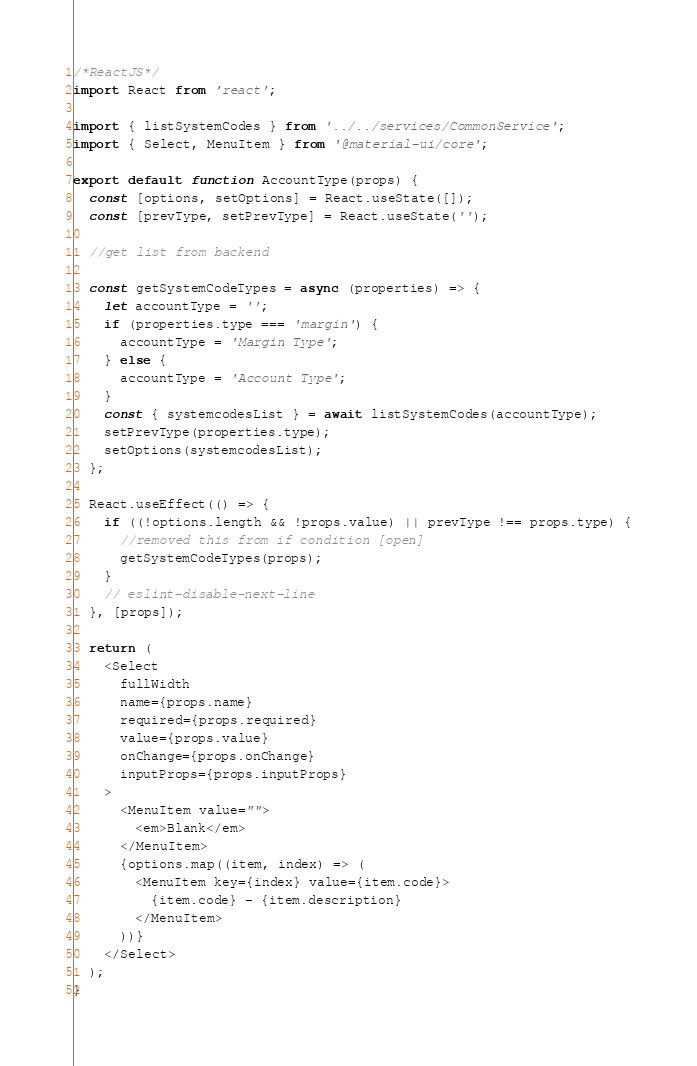<code> <loc_0><loc_0><loc_500><loc_500><_JavaScript_>/*ReactJS*/
import React from 'react';

import { listSystemCodes } from '../../services/CommonService';
import { Select, MenuItem } from '@material-ui/core';

export default function AccountType(props) {
  const [options, setOptions] = React.useState([]);
  const [prevType, setPrevType] = React.useState('');

  //get list from backend

  const getSystemCodeTypes = async (properties) => {
    let accountType = '';
    if (properties.type === 'margin') {
      accountType = 'Margin Type';
    } else {
      accountType = 'Account Type';
    }
    const { systemcodesList } = await listSystemCodes(accountType);
    setPrevType(properties.type);
    setOptions(systemcodesList);
  };

  React.useEffect(() => {
    if ((!options.length && !props.value) || prevType !== props.type) {
      //removed this from if condition [open]
      getSystemCodeTypes(props);
    }
    // eslint-disable-next-line
  }, [props]);

  return (
    <Select
      fullWidth
      name={props.name}
      required={props.required}
      value={props.value}
      onChange={props.onChange}
      inputProps={props.inputProps}
    >
      <MenuItem value="">
        <em>Blank</em>
      </MenuItem>
      {options.map((item, index) => (
        <MenuItem key={index} value={item.code}>
          {item.code} - {item.description}
        </MenuItem>
      ))}
    </Select>
  );
}
</code> 